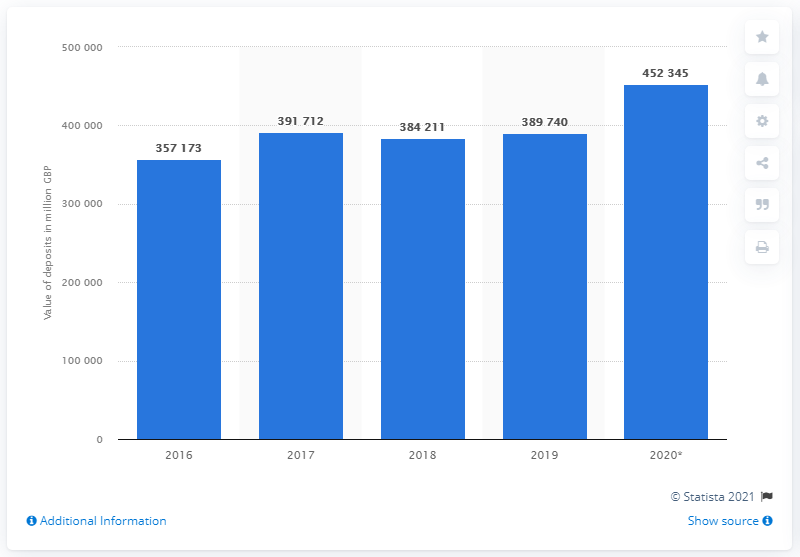Specify some key components in this picture. In 2020, the value of NatWest deposits was approximately 452,345. 